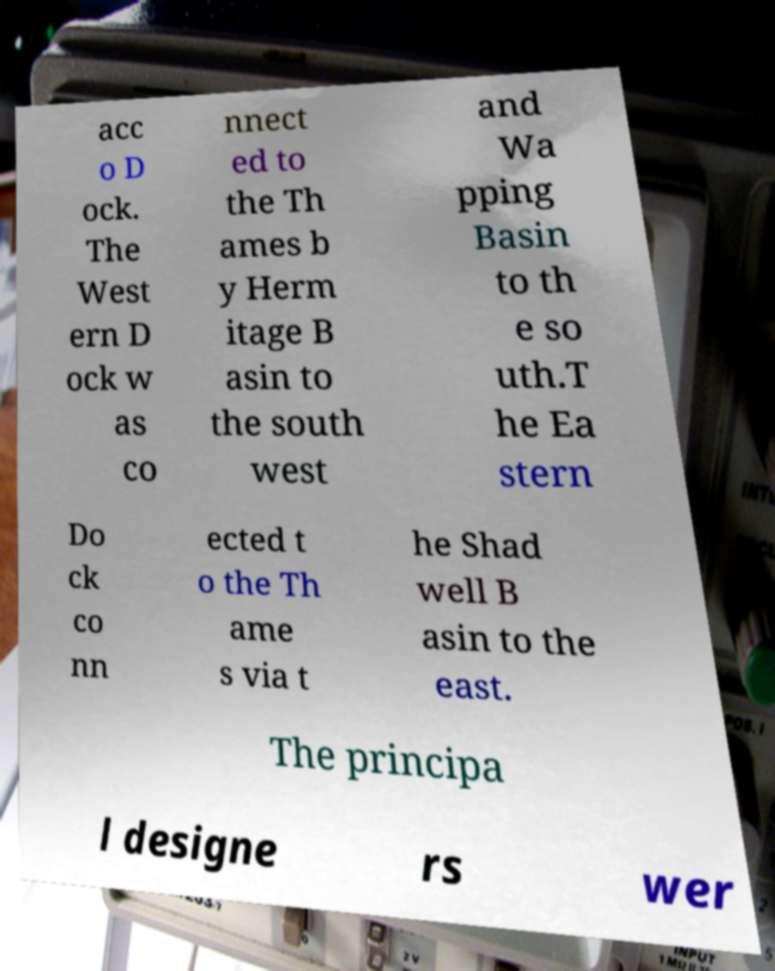I need the written content from this picture converted into text. Can you do that? acc o D ock. The West ern D ock w as co nnect ed to the Th ames b y Herm itage B asin to the south west and Wa pping Basin to th e so uth.T he Ea stern Do ck co nn ected t o the Th ame s via t he Shad well B asin to the east. The principa l designe rs wer 